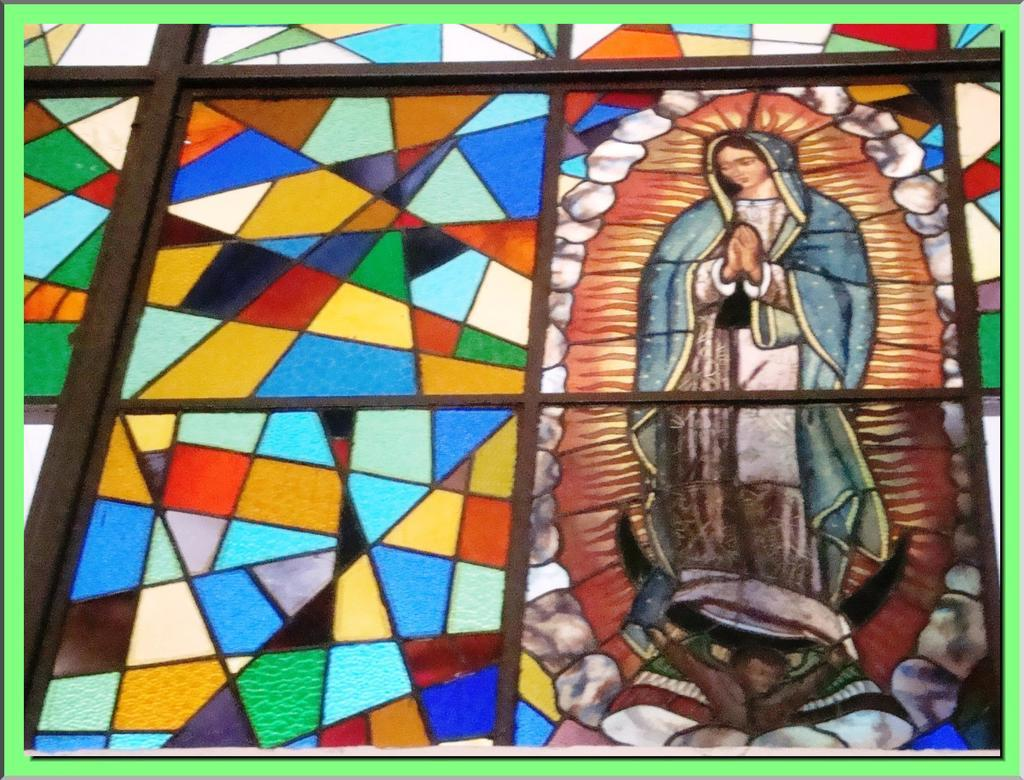What type of covering is on the windows in the image? The windows are covered with iron in the image. What can be seen on the right side of the image? There is a poster of a god on the right side of the image. What type of stage is visible in the image? There is no stage present in the image. What theory is being discussed in the image? There is no discussion or mention of any theory in the image. 